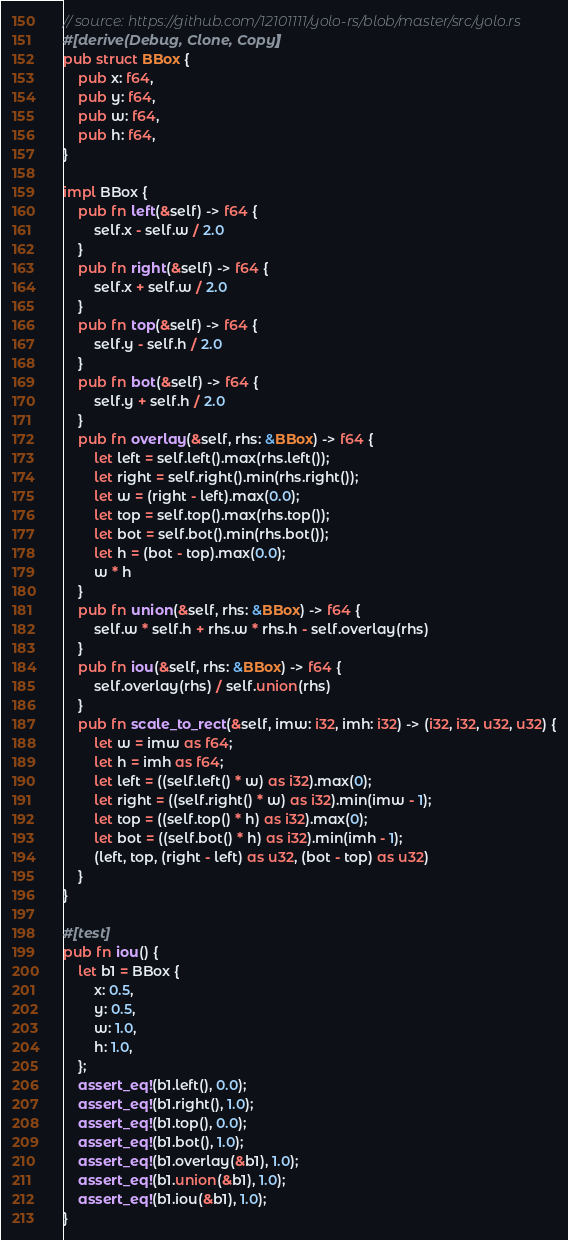<code> <loc_0><loc_0><loc_500><loc_500><_Rust_>// source: https://github.com/12101111/yolo-rs/blob/master/src/yolo.rs
#[derive(Debug, Clone, Copy)]
pub struct BBox {
    pub x: f64,
    pub y: f64,
    pub w: f64,
    pub h: f64,
}

impl BBox {
    pub fn left(&self) -> f64 {
        self.x - self.w / 2.0
    }
    pub fn right(&self) -> f64 {
        self.x + self.w / 2.0
    }
    pub fn top(&self) -> f64 {
        self.y - self.h / 2.0
    }
    pub fn bot(&self) -> f64 {
        self.y + self.h / 2.0
    }
    pub fn overlay(&self, rhs: &BBox) -> f64 {
        let left = self.left().max(rhs.left());
        let right = self.right().min(rhs.right());
        let w = (right - left).max(0.0);
        let top = self.top().max(rhs.top());
        let bot = self.bot().min(rhs.bot());
        let h = (bot - top).max(0.0);
        w * h
    }
    pub fn union(&self, rhs: &BBox) -> f64 {
        self.w * self.h + rhs.w * rhs.h - self.overlay(rhs)
    }
    pub fn iou(&self, rhs: &BBox) -> f64 {
        self.overlay(rhs) / self.union(rhs)
    }
    pub fn scale_to_rect(&self, imw: i32, imh: i32) -> (i32, i32, u32, u32) {
        let w = imw as f64;
        let h = imh as f64;
        let left = ((self.left() * w) as i32).max(0);
        let right = ((self.right() * w) as i32).min(imw - 1);
        let top = ((self.top() * h) as i32).max(0);
        let bot = ((self.bot() * h) as i32).min(imh - 1);
        (left, top, (right - left) as u32, (bot - top) as u32)
    }
}

#[test]
pub fn iou() {
    let b1 = BBox {
        x: 0.5,
        y: 0.5,
        w: 1.0,
        h: 1.0,
    };
    assert_eq!(b1.left(), 0.0);
    assert_eq!(b1.right(), 1.0);
    assert_eq!(b1.top(), 0.0);
    assert_eq!(b1.bot(), 1.0);
    assert_eq!(b1.overlay(&b1), 1.0);
    assert_eq!(b1.union(&b1), 1.0);
    assert_eq!(b1.iou(&b1), 1.0);
}
</code> 